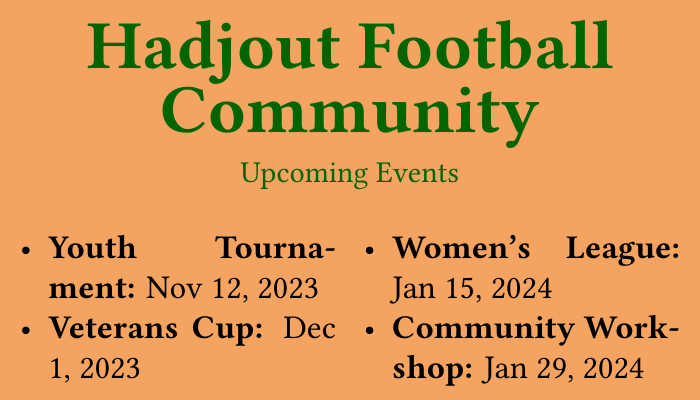what is the date of the Youth Tournament? The Youth Tournament is scheduled for November 12, 2023, as mentioned in the document.
Answer: Nov 12, 2023 when does the Women's League start? The Women's League is set to begin on January 15, 2024, according to the upcoming events listed.
Answer: Jan 15, 2024 how many events are listed in total? There are four upcoming events mentioned in the document related to the Hadjout football community.
Answer: 4 what is the contact email for more information? The email provided for registration and more information is contact@hadjoutfootballcommunity.com.
Answer: contact@hadjoutfootballcommunity.com what is the name of the community workshop? The community workshop is simply referred to as the "Community Workshop" in the document.
Answer: Community Workshop which event occurs first among the listed events? The Youth Tournament on November 12, 2023, is the first event listed in order of date.
Answer: Youth Tournament what type of event is scheduled for December 1, 2023? The event on December 1, 2023, is the Veterans Cup based on the document information.
Answer: Veterans Cup what is the phone number for registration inquiries? The document provides the phone number +213 550 987 654 for registration and inquiries.
Answer: +213 550 987 654 